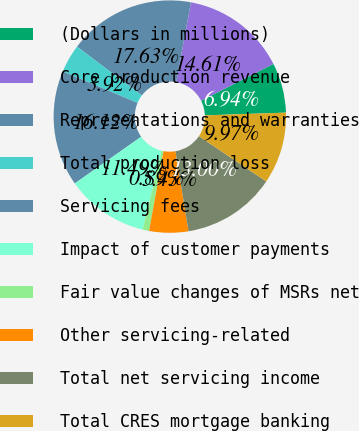Convert chart to OTSL. <chart><loc_0><loc_0><loc_500><loc_500><pie_chart><fcel>(Dollars in millions)<fcel>Core production revenue<fcel>Representations and warranties<fcel>Total production loss<fcel>Servicing fees<fcel>Impact of customer payments<fcel>Fair value changes of MSRs net<fcel>Other servicing-related<fcel>Total net servicing income<fcel>Total CRES mortgage banking<nl><fcel>6.94%<fcel>14.61%<fcel>17.63%<fcel>3.92%<fcel>16.12%<fcel>11.49%<fcel>0.89%<fcel>5.43%<fcel>13.0%<fcel>9.97%<nl></chart> 